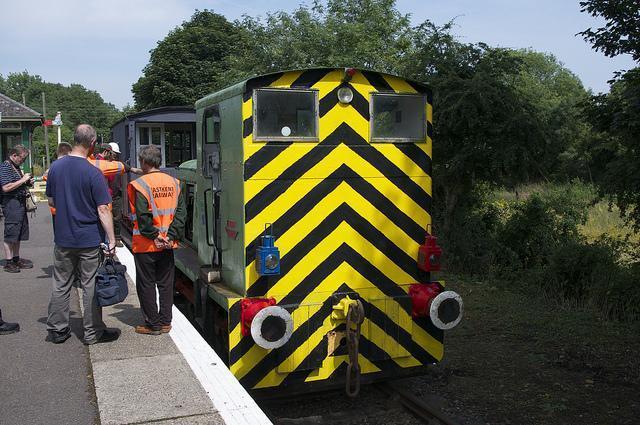How many people are in the picture?
Give a very brief answer. 3. 